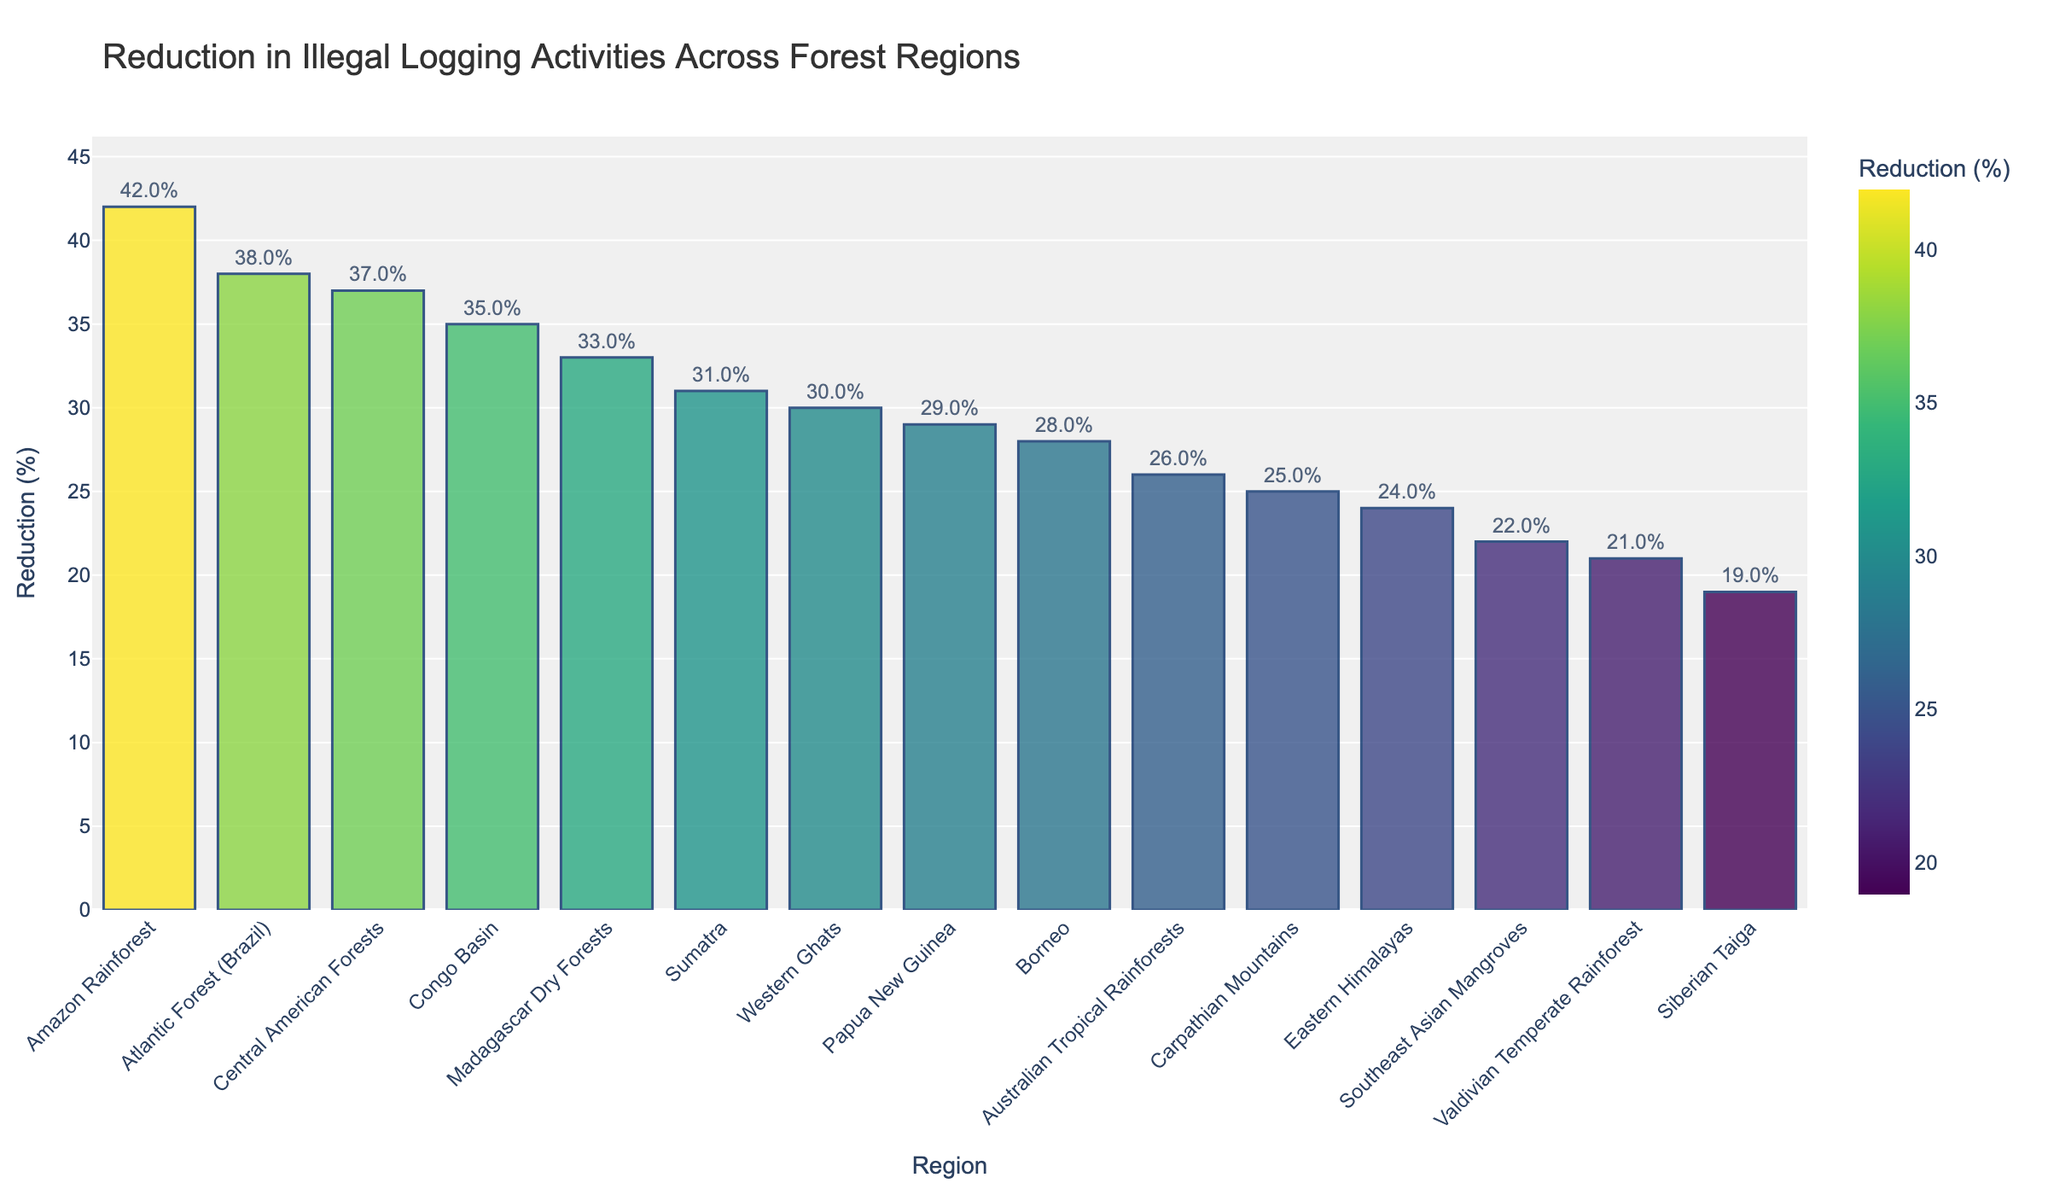Which forest region has the highest reduction in illegal logging activities? The region with the highest bar on the chart, indicating the greatest reduction, is the Amazon Rainforest.
Answer: Amazon Rainforest Which forest region has the lowest reduction in illegal logging activities? The region with the shortest bar on the chart, indicating the smallest reduction, is the Siberian Taiga.
Answer: Siberian Taiga Are there any regions with the same amount of illegal logging reduction? Each bar on the chart has a different height, so no two regions have the same reduction percentage.
Answer: No What is the difference in illegal logging reduction between the Amazon Rainforest and the Siberian Taiga? The bar for the Amazon Rainforest shows a 42% reduction, and the bar for the Siberian Taiga indicates a 19% reduction. The difference is 42% - 19% = 23%.
Answer: 23% What is the average illegal logging reduction percentage across all regions? Sum all reduction percentages and then divide by the number of regions: sum = 42 + 35 + 28 + 31 + 19 + 24 + 37 + 22 + 33 + 26 + 29 + 38 + 21 + 30 + 25 = 420, number of regions = 15, so average = 420 / 15 = 28%.
Answer: 28% Which region has approximately half the reduction percentage of the Amazon Rainforest? The Amazon Rainforest has a 42% reduction, so half of that is 21%. The Valdivian Temperate Rainforest, with a 21% reduction, fits this criterion.
Answer: Valdivian Temperate Rainforest Name three regions with an illegal logging reduction percentage greater than 30%. The regions with bars taller than the 30% mark are Amazon Rainforest (42%), Congo Basin (35%), Central American Forests (37%), Madagascar Dry Forests (33%), and Atlantic Forest (38%). Three of these regions are the Amazon Rainforest, Congo Basin, and Central American Forests.
Answer: Amazon Rainforest, Congo Basin, Central American Forests What is the median reduction percentage of illegal logging across these regions? Sort the reduction percentages in ascending order: [19, 21, 22, 24, 25, 26, 28, 29, 30, 31, 33, 35, 37, 38, 42]. The median is the middle value, so the 8th value in this ordered list is 29%.
Answer: 29% Which region has a reduction percentage closer to the average reduction than the others? The average reduction percentage is 28%. The region with a reduction percentage closest to 28% is Borneo, which has a 28% reduction.
Answer: Borneo Among the regions with a reduction percentage lower than 25%, which one has the highest reduction? The regions with a reduction percentage lower than 25% are Siberian Taiga (19%), Eastern Himalayas (24%), Southeast Asian Mangroves (22%), and Valdivian Temperate Rainforest (21%). The highest among these is the Eastern Himalayas with 24%.
Answer: Eastern Himalayas 